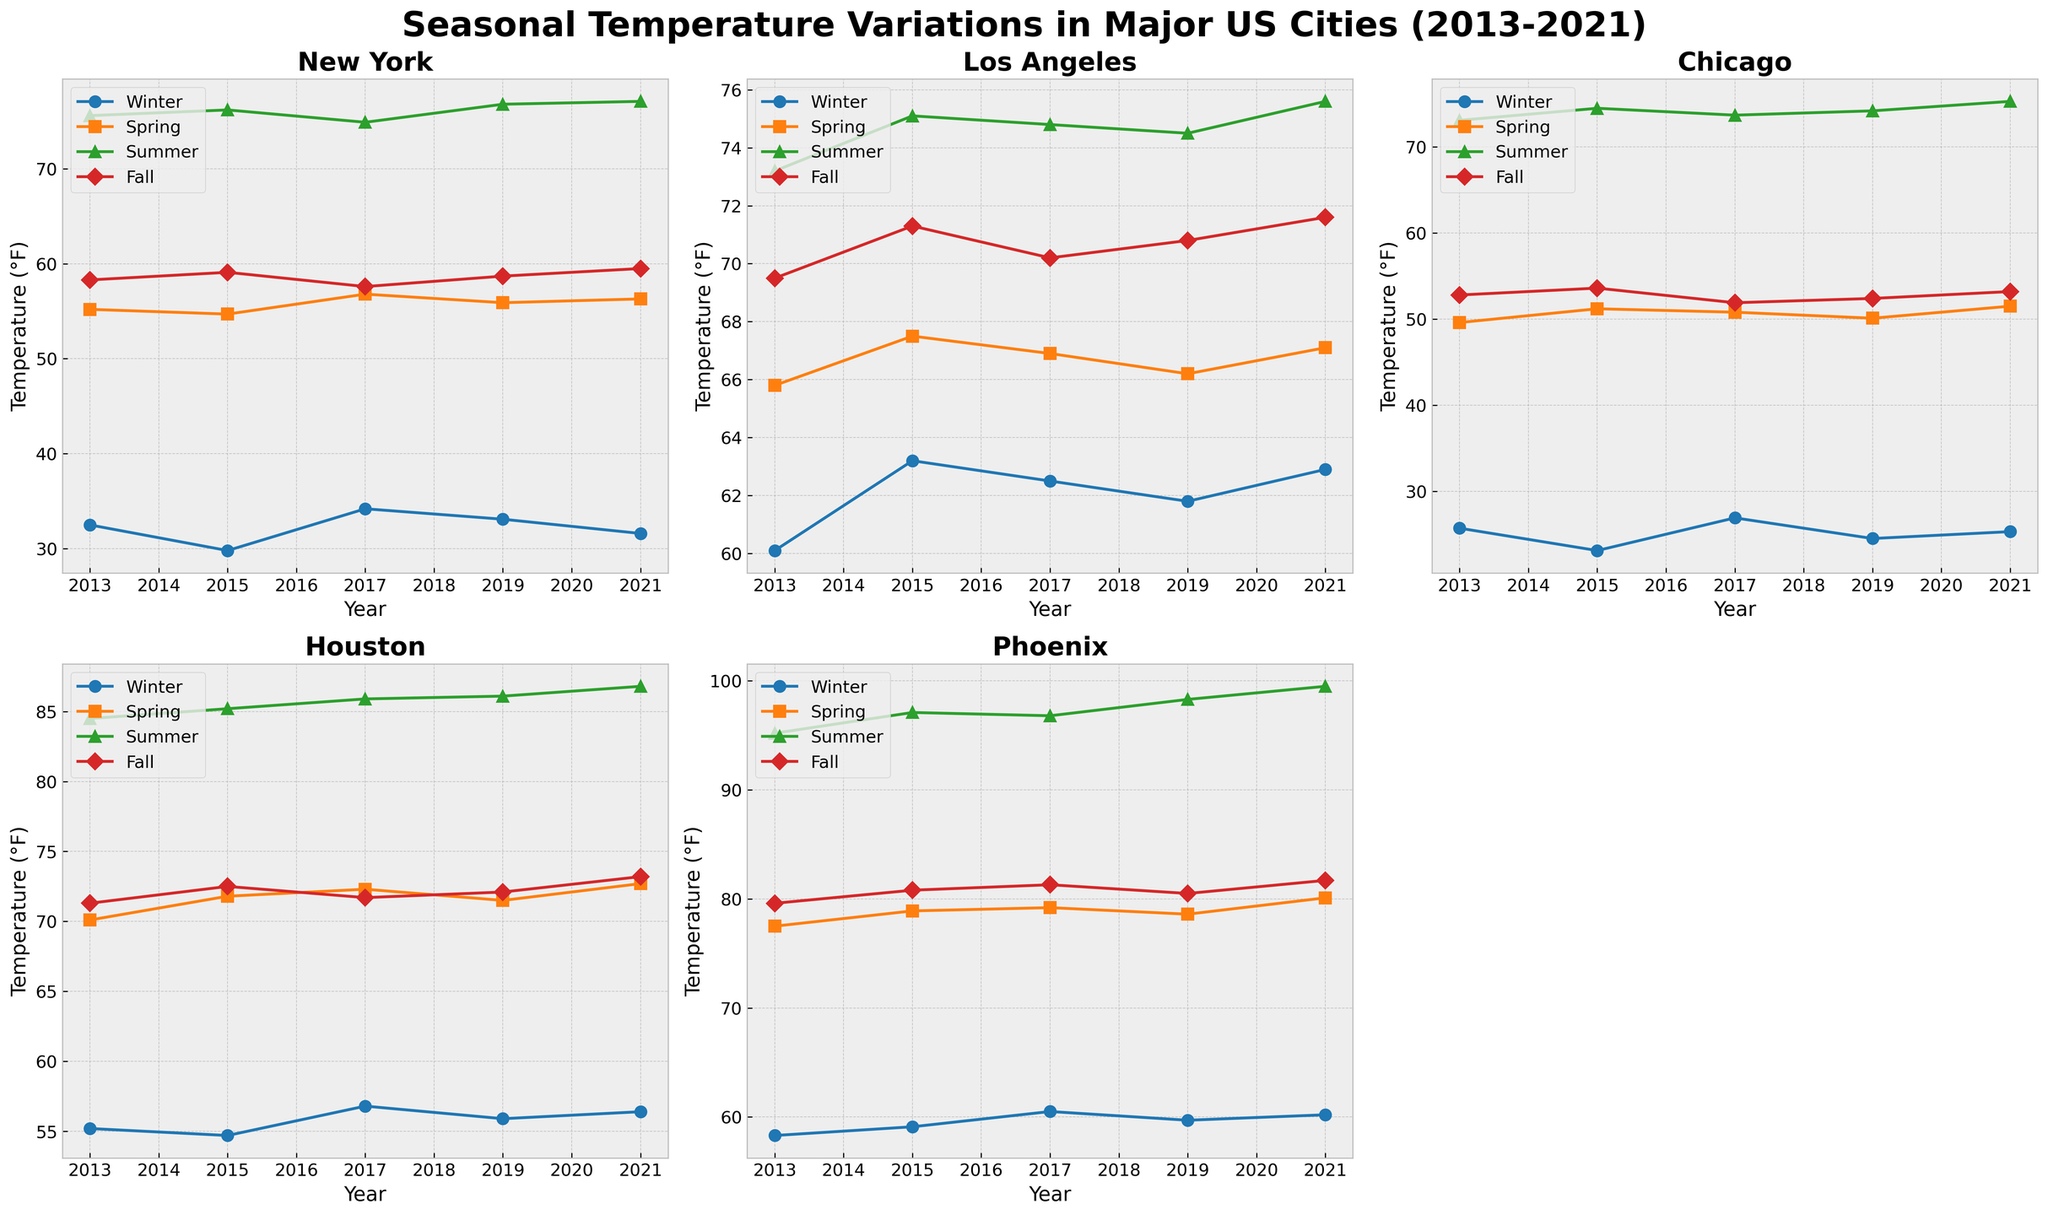What is the title of the figure? The title is displayed at the top of the figure and reads "Seasonal Temperature Variations in Major US Cities (2013-2021)"
Answer: Seasonal Temperature Variations in Major US Cities (2013-2021) Which city has the highest summer temperature in 2021? In the subplot for each city, the summer temperature for 2021 can be checked. Phoenix has the highest recorded summer temperature of 99.5°F in 2021.
Answer: Phoenix What is the temperature trend in New York during winters over the displayed years? By looking at the subplot for New York, observe the winter temperatures across different years: 32.5 (2013), 29.8 (2015), 34.2 (2017), 33.1 (2019), 31.6 (2021). The trend fluctuates slightly but generally remains in the low 30s.
Answer: Slight variations in the low 30s Which seasons are represented in the line charts? Each subplot has a legend indicating the colored lines for each season. The seasons included are Winter, Spring, Summer, and Fall.
Answer: Winter, Spring, Summer, Fall How does the winter temperature in Chicago in 2013 compare to the winter temperature in New York in the same year? In the subplots for Chicago and New York, check the winter temperature data for 2013. Chicago's winter temperature in 2013 is 25.7°F, and New York's is 32.5°F. New York is warmer.
Answer: New York is warmer What is the average fall temperature in Los Angeles over the displayed years? Look at the fall temperatures in the Los Angeles subplot for the years 2013 (69.5), 2015 (71.3), 2017 (70.2), 2019 (70.8), 2021 (71.6). The average is calculated by summing these and dividing by 5, i.e., (69.5 + 71.3 + 70.2 + 70.8 + 71.6)/5 = 70.68
Answer: 70.68°F Which city shows the most significant increase in summer temperatures from 2013 to 2021? Check the summer temperatures for all cities in 2013 and 2021: 
New York: 75.6 to 77.1 (increase 1.5), Los Angeles: 73.2 to 75.6 (increase 2.4), Chicago: 73.1 to 75.3 (increase 2.2), Houston: 84.5 to 86.8 (increase 2.3), Phoenix: 95.2 to 99.5 (increase 4.3). Phoenix has the most significant increase (4.3)
Answer: Phoenix Compare the spring temperature trends between Houston and Phoenix from 2013 to 2021. Looking at the spring temperatures for these cities across the years: 
Houston: 70.1 (2013), 71.8 (2015), 72.3 (2017), 71.5 (2019), 72.7 (2021)
Phoenix: 77.5 (2013), 78.9 (2015), 79.2 (2017), 78.6 (2019), 80.1 (2021)
Both cities show a rising trend, but Phoenix has consistently higher spring temperatures than Houston.
Answer: Phoenix consistently higher, both rising In which season does Chicago show the least variance in temperature over the years? Look at the winter, spring, summer, fall temperatures in Chicago's subplot to identify the least fluctuating:
Winter (25.7, 23.1, 26.9, 24.5, 25.3), Spring (49.6, 51.2, 50.8, 50.1, 51.5), Summer (73.1, 74.5, 73.7, 74.2, 75.3), Fall (52.8, 53.6, 51.9, 52.4, 53.2)
The summer season shows the least variance in temperatures.
Answer: Summer 